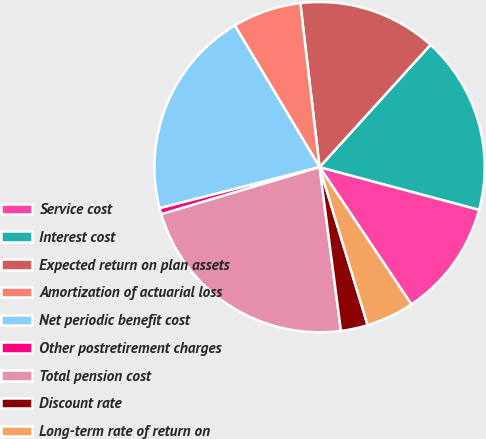Convert chart. <chart><loc_0><loc_0><loc_500><loc_500><pie_chart><fcel>Service cost<fcel>Interest cost<fcel>Expected return on plan assets<fcel>Amortization of actuarial loss<fcel>Net periodic benefit cost<fcel>Other postretirement charges<fcel>Total pension cost<fcel>Discount rate<fcel>Long-term rate of return on<nl><fcel>11.46%<fcel>17.43%<fcel>13.58%<fcel>6.72%<fcel>20.42%<fcel>0.6%<fcel>22.46%<fcel>2.64%<fcel>4.68%<nl></chart> 